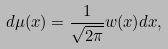Convert formula to latex. <formula><loc_0><loc_0><loc_500><loc_500>d \mu ( x ) = \frac { 1 } { \sqrt { 2 \pi } } w ( x ) d x ,</formula> 